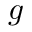<formula> <loc_0><loc_0><loc_500><loc_500>g</formula> 